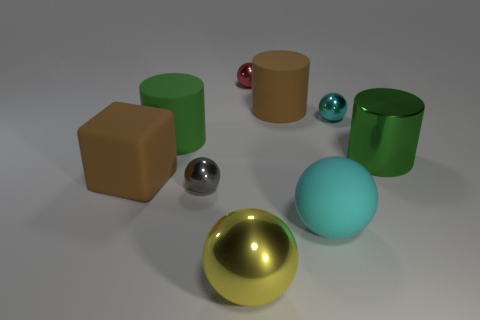What color is the large metallic ball?
Give a very brief answer. Yellow. What is the size of the brown thing behind the brown block?
Your answer should be very brief. Large. What number of small metal things are the same color as the cube?
Give a very brief answer. 0. There is a big green thing on the right side of the yellow object; is there a big metallic cylinder behind it?
Keep it short and to the point. No. Is the color of the tiny metallic ball that is in front of the small cyan object the same as the matte object in front of the big block?
Your response must be concise. No. There is a shiny cylinder that is the same size as the brown rubber cube; what is its color?
Provide a succinct answer. Green. Is the number of big matte cubes that are behind the big brown rubber cube the same as the number of tiny cyan things that are in front of the yellow ball?
Provide a succinct answer. Yes. What is the material of the big green thing that is to the right of the small metal object in front of the cube?
Your answer should be very brief. Metal. What number of things are either shiny spheres or cylinders?
Offer a terse response. 7. What is the size of the thing that is the same color as the large rubber block?
Offer a terse response. Large. 